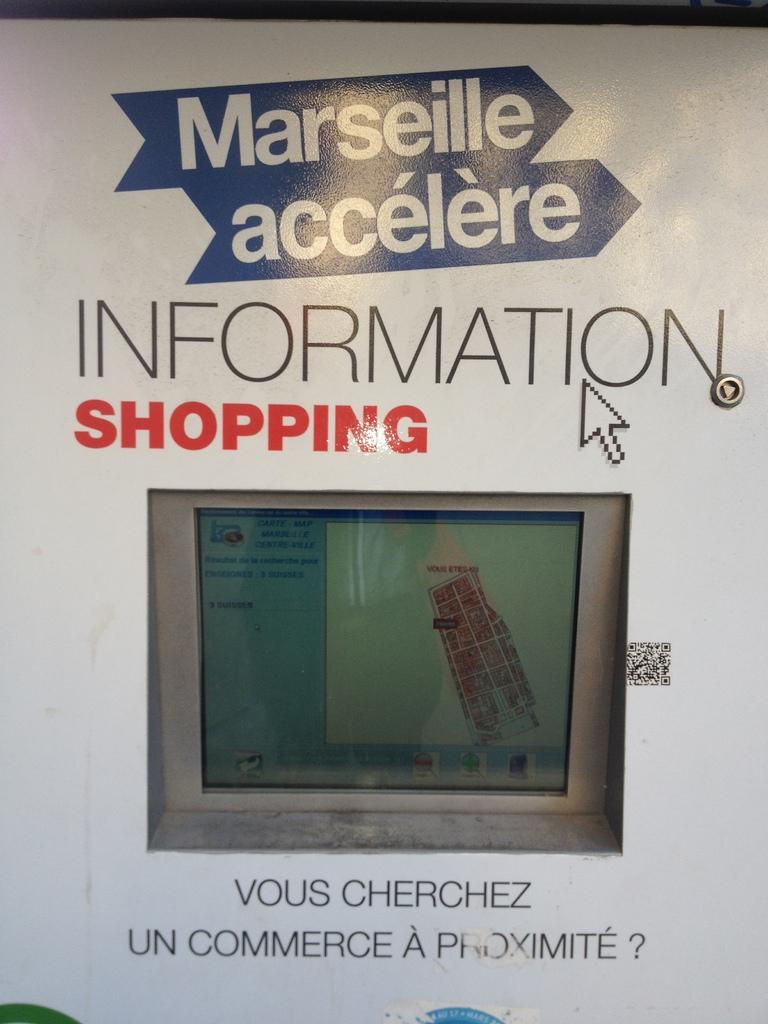What does the red text on the sign say?
Make the answer very short. Shopping. This is what kind of information?
Provide a short and direct response. Shopping. 